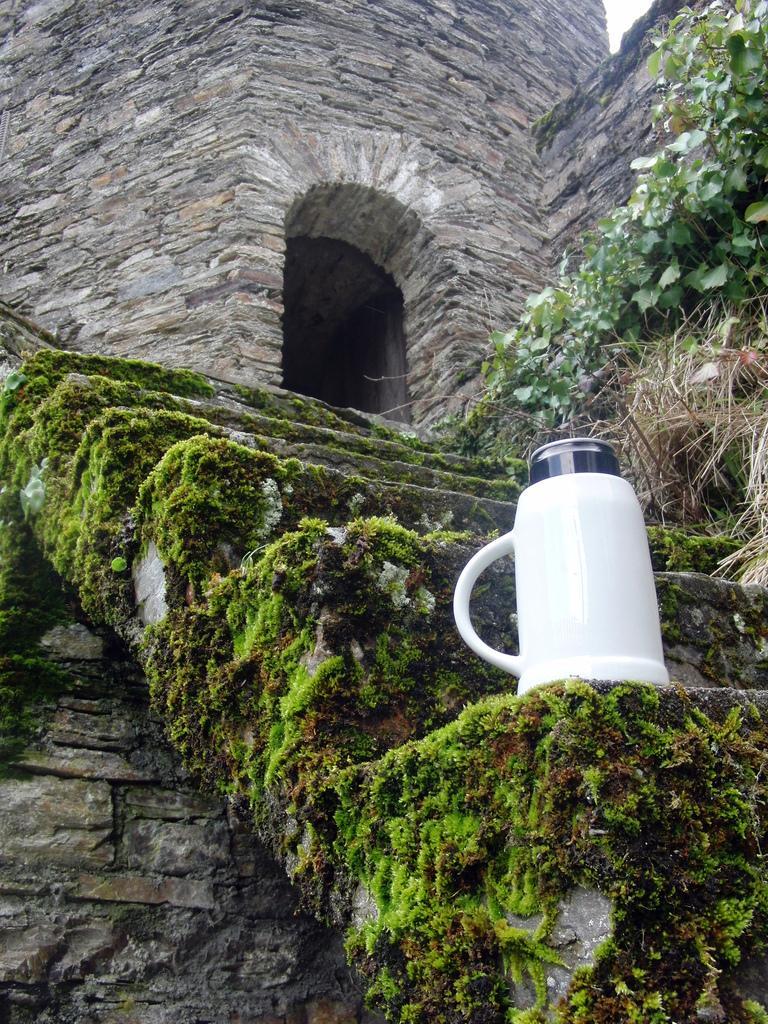How would you summarize this image in a sentence or two? In this image there is a flask on the stairs, on the stairs there is grass. Behind the stairs there is a rock wall. On the right side of the image there are plants and dried grass. Beneath the stairs there is a wall. 